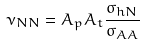<formula> <loc_0><loc_0><loc_500><loc_500>\nu _ { N N } = A _ { p } A _ { t } \frac { \sigma _ { h N } } { \sigma _ { A A } }</formula> 